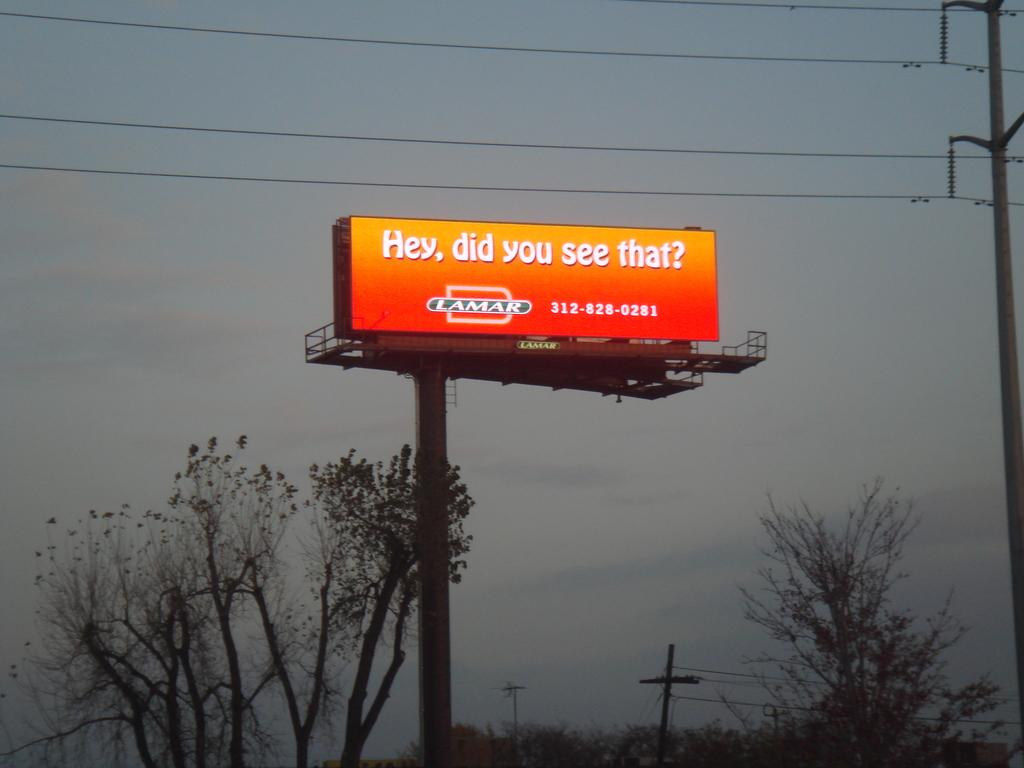<image>
Relay a brief, clear account of the picture shown. A company called Lamar poses a cryptic question with an orange billboard. 